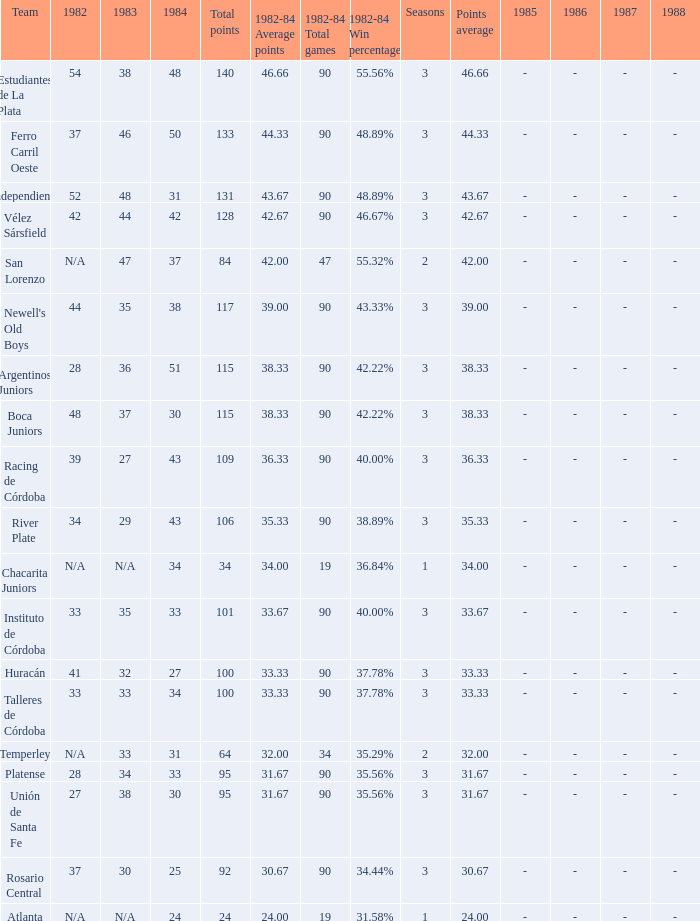What is the points total for the team with points average more than 34, 1984 score more than 37 and N/A in 1982? 0.0. 